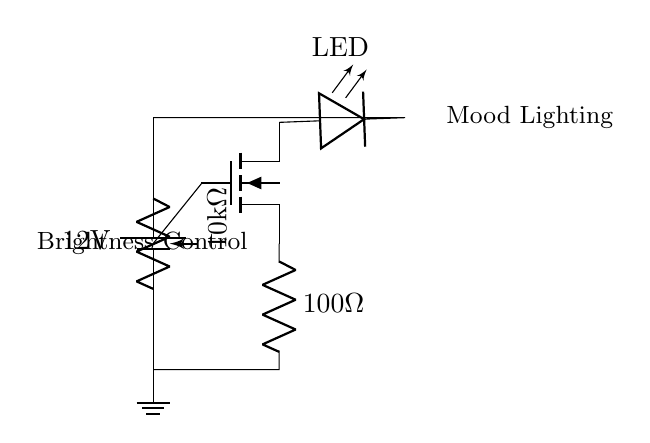What is the voltage of the power supply? The voltage is 12 volts, as indicated by the battery symbol labeled in the circuit diagram.
Answer: 12 volts What component is used for brightness control? A potentiometer labeled as 10k ohms is used for adjusting brightness in the circuit.
Answer: Potentiometer What type of LED is used in the circuit? The circuit diagram does not specify the type of LED, but it does label a component simply as LED, indicating a light-emitting diode is present.
Answer: LED How many ohms is the resistor in the circuit? The resistor labeled in the circuit has a value of 100 ohms, as stated next to the resistor symbol.
Answer: 100 ohms What component controls the current to the LED? The MOSFET present in the circuit diagram is responsible for controlling the current flowing to the LED.
Answer: MOSFET What happens when the potentiometer is adjusted? Adjusting the potentiometer changes its resistance, which in turn modulates the gate voltage of the MOSFET, affecting the brightness of the LED.
Answer: Brightness changes Which component is indicated to be grounded? The ground symbol at the bottom of the circuit diagram is connected to the negative terminal of the power supply, marking the ground point.
Answer: Ground 